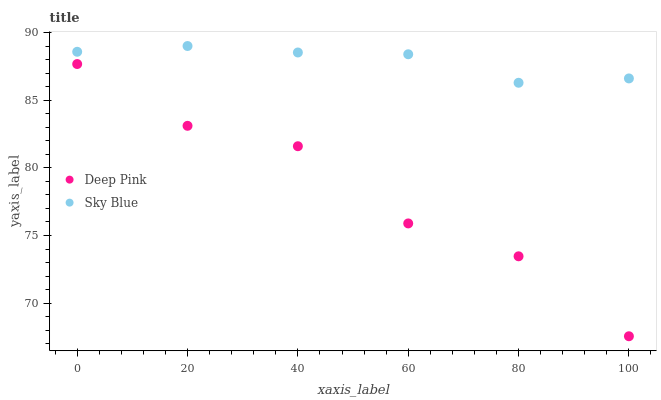Does Deep Pink have the minimum area under the curve?
Answer yes or no. Yes. Does Sky Blue have the maximum area under the curve?
Answer yes or no. Yes. Does Deep Pink have the maximum area under the curve?
Answer yes or no. No. Is Sky Blue the smoothest?
Answer yes or no. Yes. Is Deep Pink the roughest?
Answer yes or no. Yes. Is Deep Pink the smoothest?
Answer yes or no. No. Does Deep Pink have the lowest value?
Answer yes or no. Yes. Does Sky Blue have the highest value?
Answer yes or no. Yes. Does Deep Pink have the highest value?
Answer yes or no. No. Is Deep Pink less than Sky Blue?
Answer yes or no. Yes. Is Sky Blue greater than Deep Pink?
Answer yes or no. Yes. Does Deep Pink intersect Sky Blue?
Answer yes or no. No. 